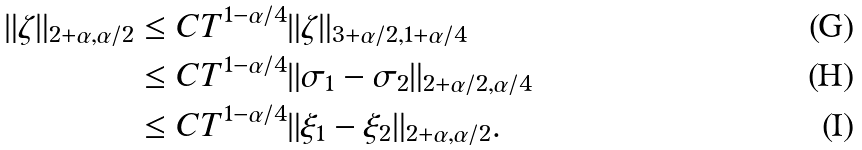Convert formula to latex. <formula><loc_0><loc_0><loc_500><loc_500>\| \zeta \| _ { 2 + \alpha , \alpha / 2 } & \leq C T ^ { 1 - \alpha / 4 } \| \zeta \| _ { 3 + \alpha / 2 , 1 + \alpha / 4 } \\ & \leq C T ^ { 1 - \alpha / 4 } \| \sigma _ { 1 } - \sigma _ { 2 } \| _ { 2 + \alpha / 2 , \alpha / 4 } \\ & \leq C T ^ { 1 - \alpha / 4 } \| \xi _ { 1 } - \xi _ { 2 } \| _ { 2 + \alpha , \alpha / 2 } .</formula> 